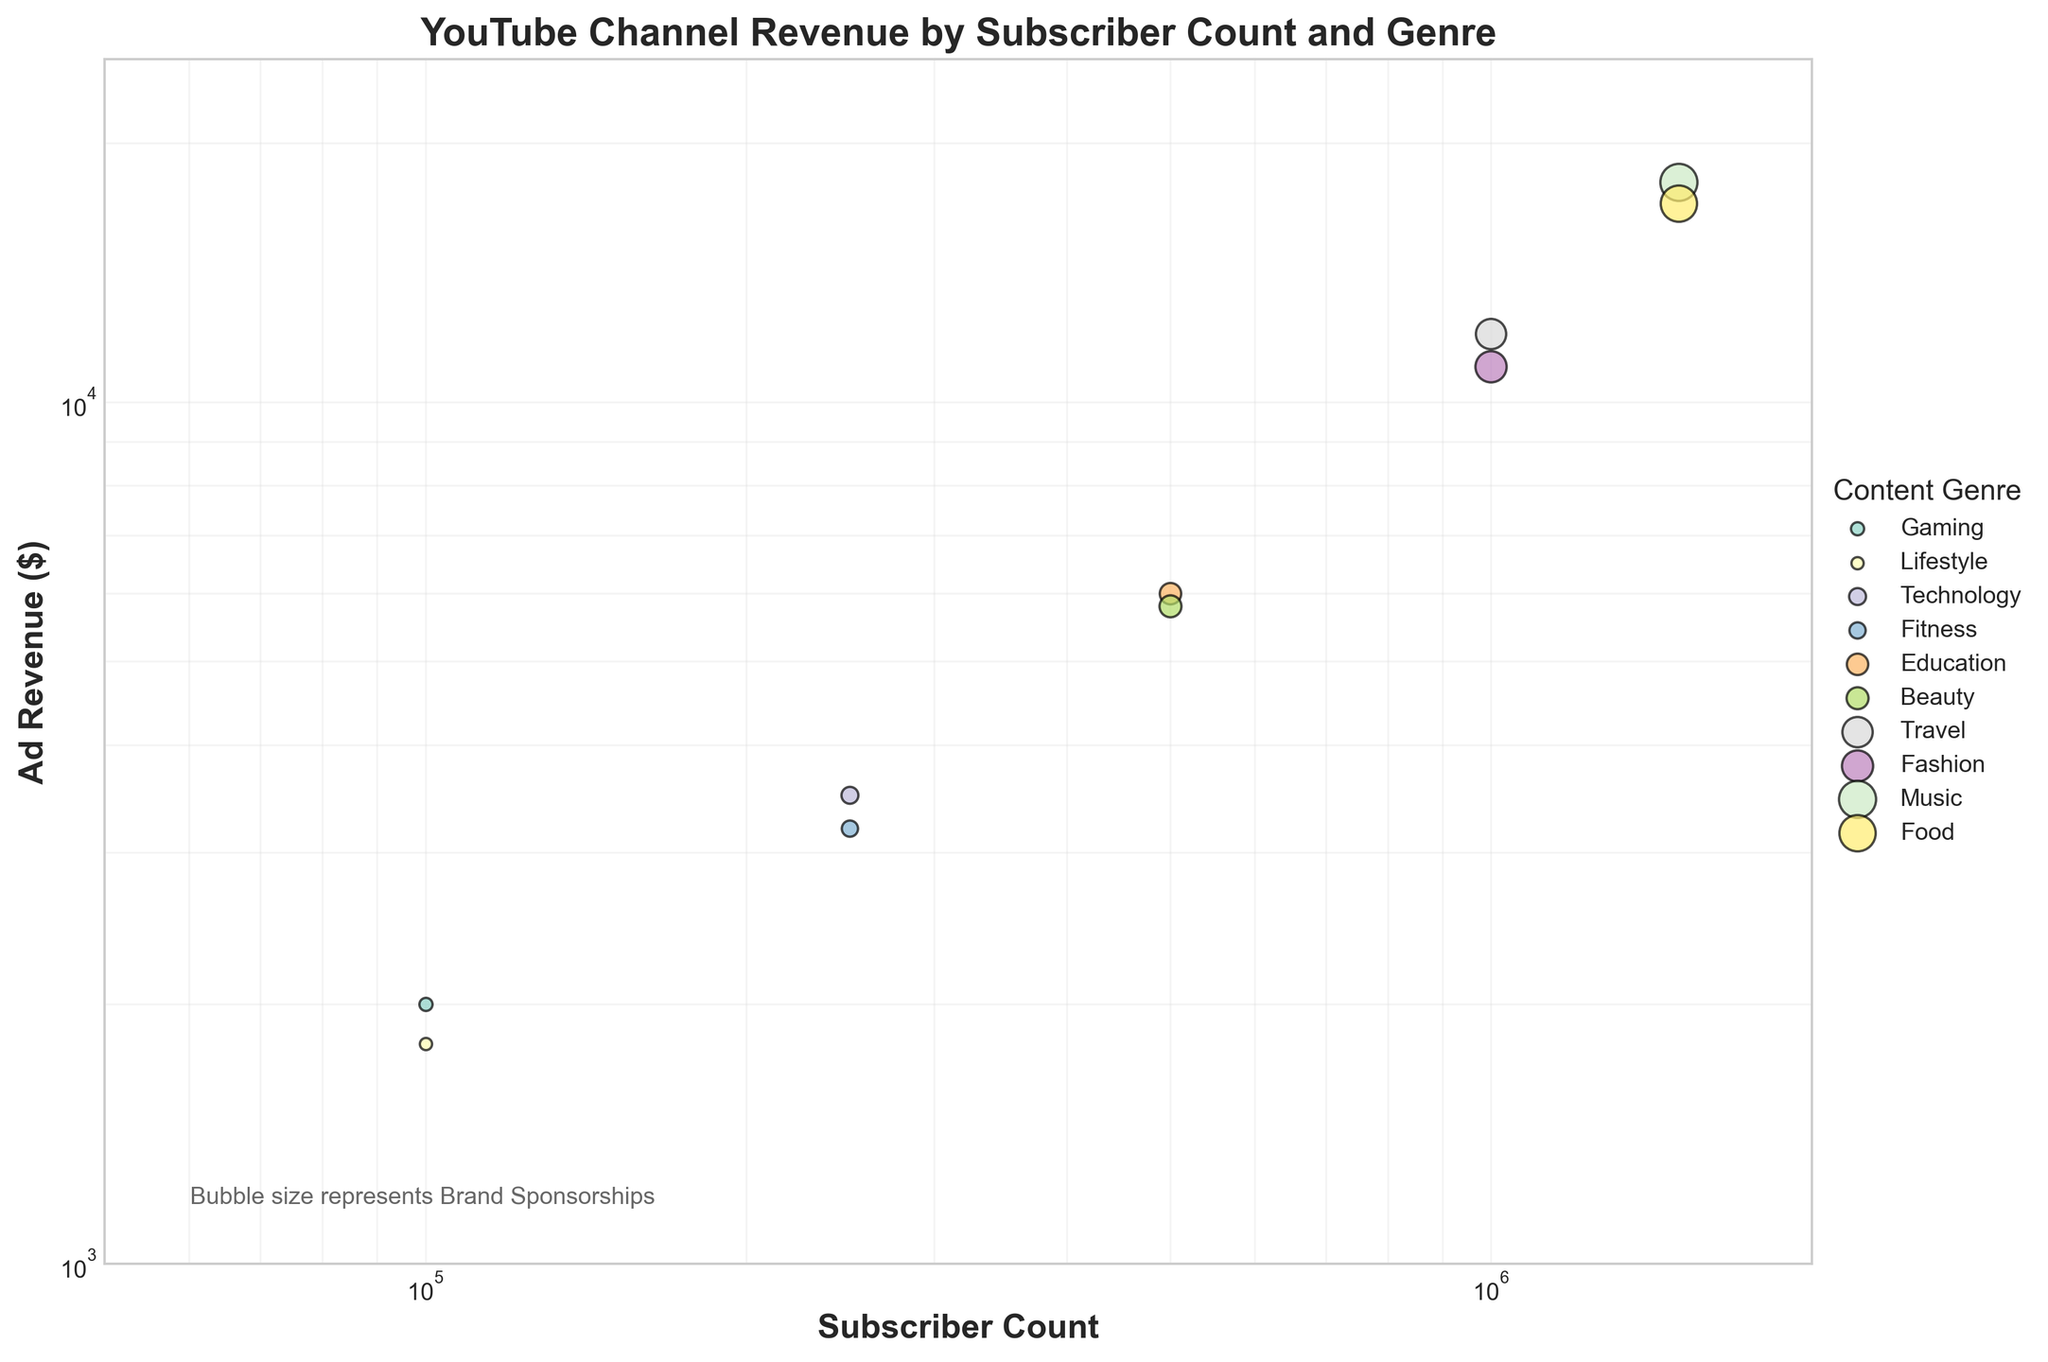What's the title of the figure? The title is usually placed at the top of the chart. Here, it reads "YouTube Channel Revenue by Subscriber Count and Genre".
Answer: YouTube Channel Revenue by Subscriber Count and Genre What does the x-axis represent? The x-axis labels indicate what the horizontal axis represents. In this case, it is labeled "Subscriber Count".
Answer: Subscriber Count What does the y-axis represent? The y-axis labels indicate what the vertical axis represents. In this figure, it is labeled "Ad Revenue ($)".
Answer: Ad Revenue ($) Which Content Genre has the highest Ad Revenue at 1,000,000 subscribers? By looking at the data points for 1,000,000 subscribers and checking the corresponding Ad Revenue values, you see that the highest Ad Revenue is for the Travel genre.
Answer: Travel How many genres are represented in the scatter plot? The legend indicates the different genres. Counting the genres listed in the legend, we see there are 10.
Answer: 10 What feature of the bubbles represents Brand Sponsorships? The figure's description mentions that the bubble size represents Brand Sponsorships, and an explanatory note is also present in the figure.
Answer: Bubble size Which genre has the largest bubble (Brand Sponsorship) at 250,000 subscribers? By examining the 250,000 subscriber mark and checking bubble sizes, Technology has the largest bubble among genres at this subscriber count.
Answer: Technology Compare the Ad Revenue for the Education genre and Beauty genre at 500,000 subscribers. Which is higher? At 500,000 subscribers, the Ad Revenue for the Education genre is slightly higher than that for the Beauty genre. Specifically, Education has $6,000, while Beauty has $5,800.
Answer: Education Among channels with 1,500,000 subscribers, which genre has the higher Merchandise Sales, Music or Food? Referring to the dataset, Music has higher Merchandise Sales at 1,500,000 subscribers ($6,000) compared to Food ($6,500).
Answer: Food What is the general trend in Ad Revenue as Subscriber Count increases? The plot shows that Ad Revenue increases as Subscriber Count increases. This can be observed by the upward trend in data points.
Answer: Increasing 